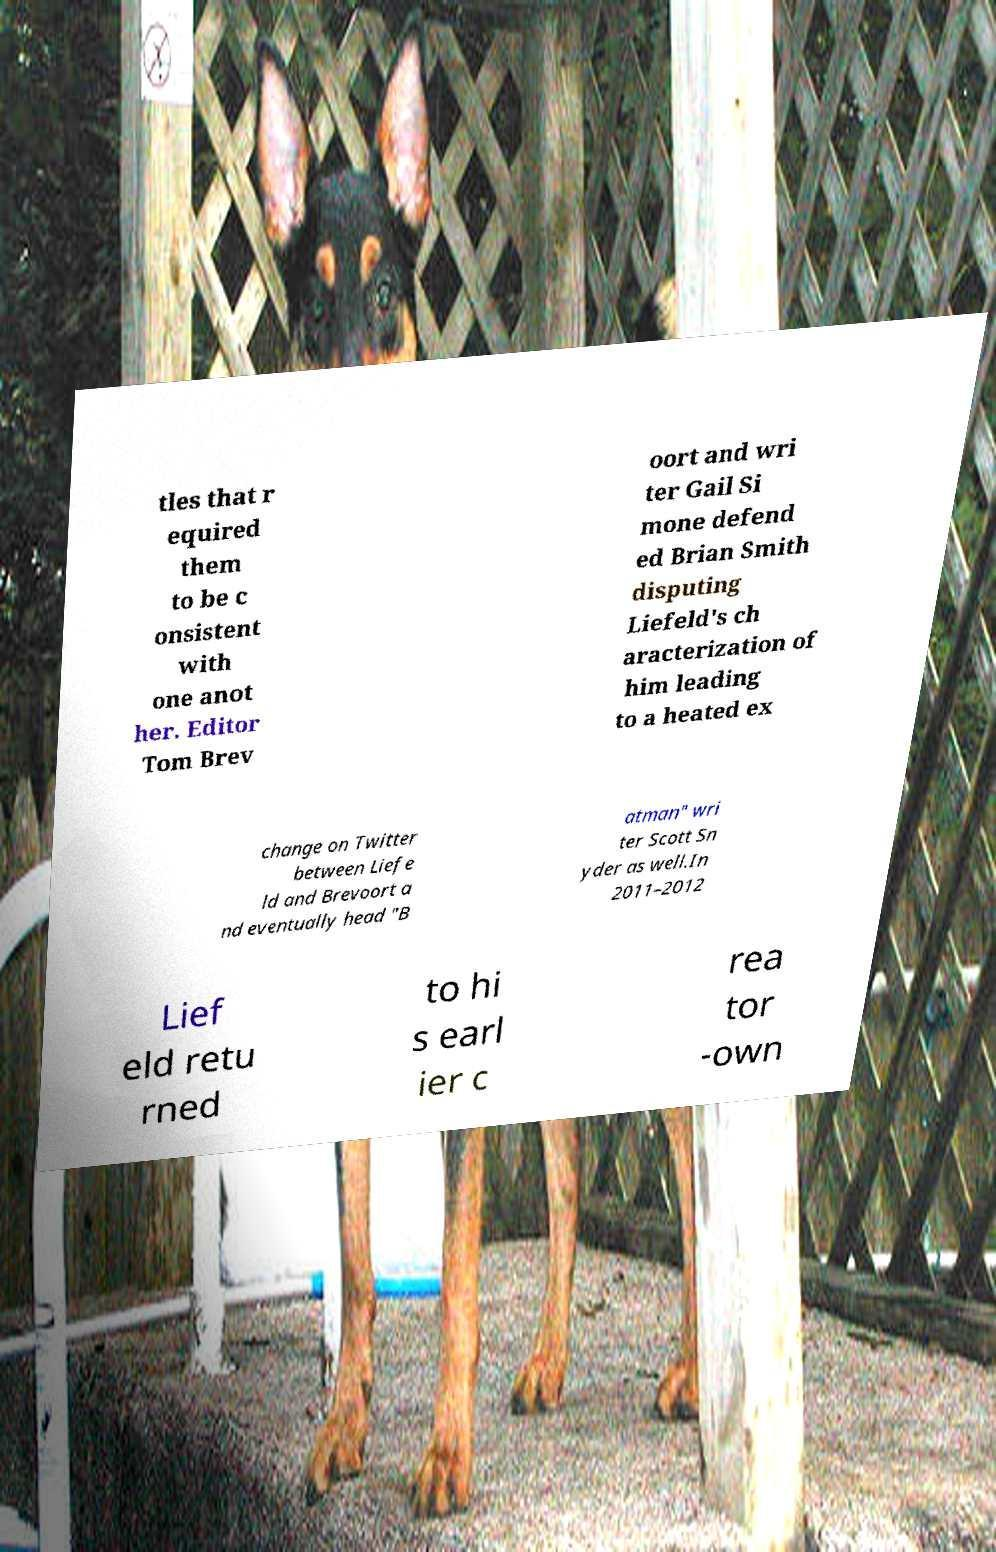Please identify and transcribe the text found in this image. tles that r equired them to be c onsistent with one anot her. Editor Tom Brev oort and wri ter Gail Si mone defend ed Brian Smith disputing Liefeld's ch aracterization of him leading to a heated ex change on Twitter between Liefe ld and Brevoort a nd eventually head "B atman" wri ter Scott Sn yder as well.In 2011–2012 Lief eld retu rned to hi s earl ier c rea tor -own 